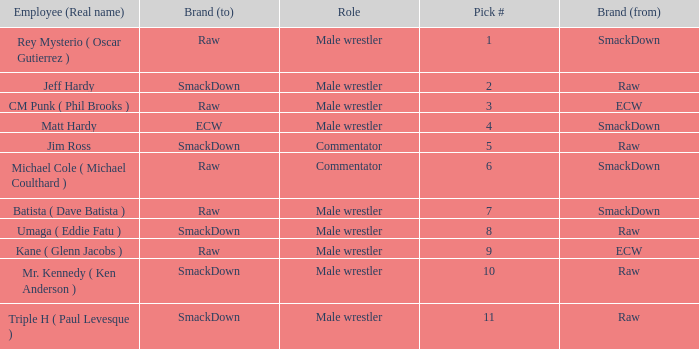What role did Pick # 10 have? Male wrestler. 